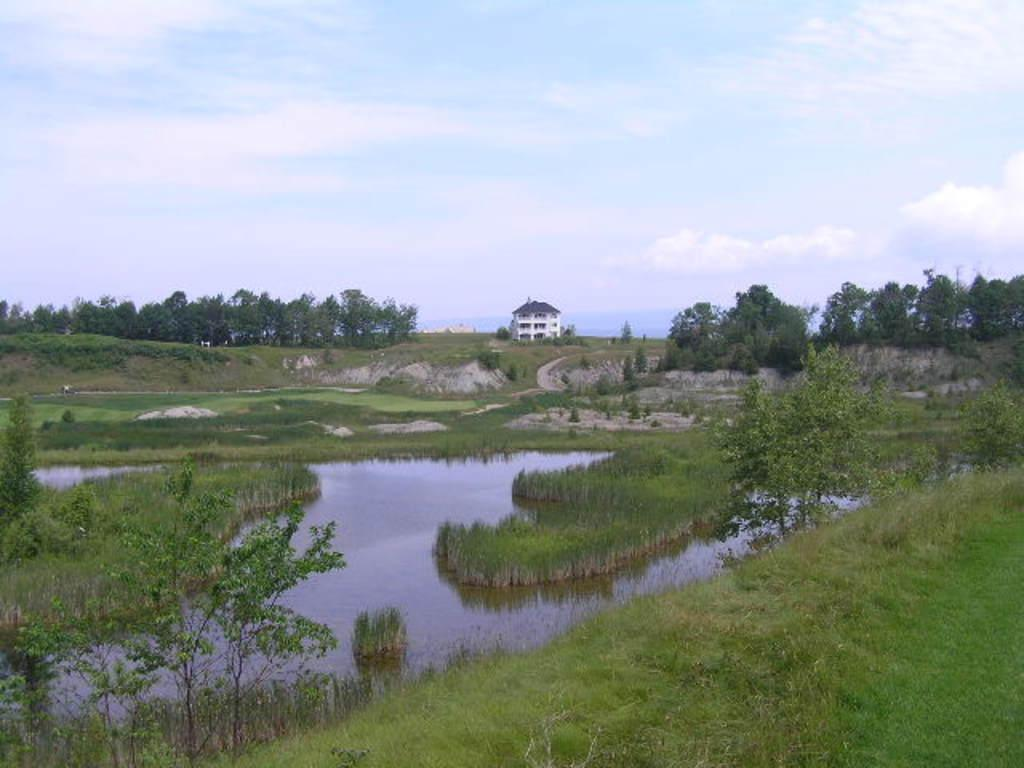What type of natural environment is depicted in the image? The image contains water, grass, plants, and trees, which are all elements of a natural environment. Can you describe the man-made structure in the image? There is a building in the image. What is visible in the sky in the image? Clouds are visible in the sky in the image. How many pockets can be seen on the trees in the image? There are no pockets present on the trees in the image, as trees do not have pockets. What type of boat is visible in the image? There is no boat present in the image. 